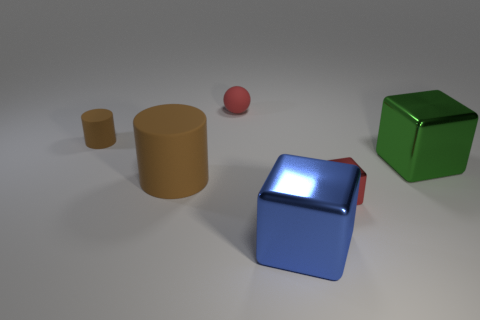Subtract all gray cylinders. Subtract all red spheres. How many cylinders are left? 2 Add 3 large green things. How many objects exist? 9 Subtract all spheres. How many objects are left? 5 Add 6 large cyan metallic objects. How many large cyan metallic objects exist? 6 Subtract 0 brown spheres. How many objects are left? 6 Subtract all big cyan matte cylinders. Subtract all large cylinders. How many objects are left? 5 Add 5 tiny red matte things. How many tiny red matte things are left? 6 